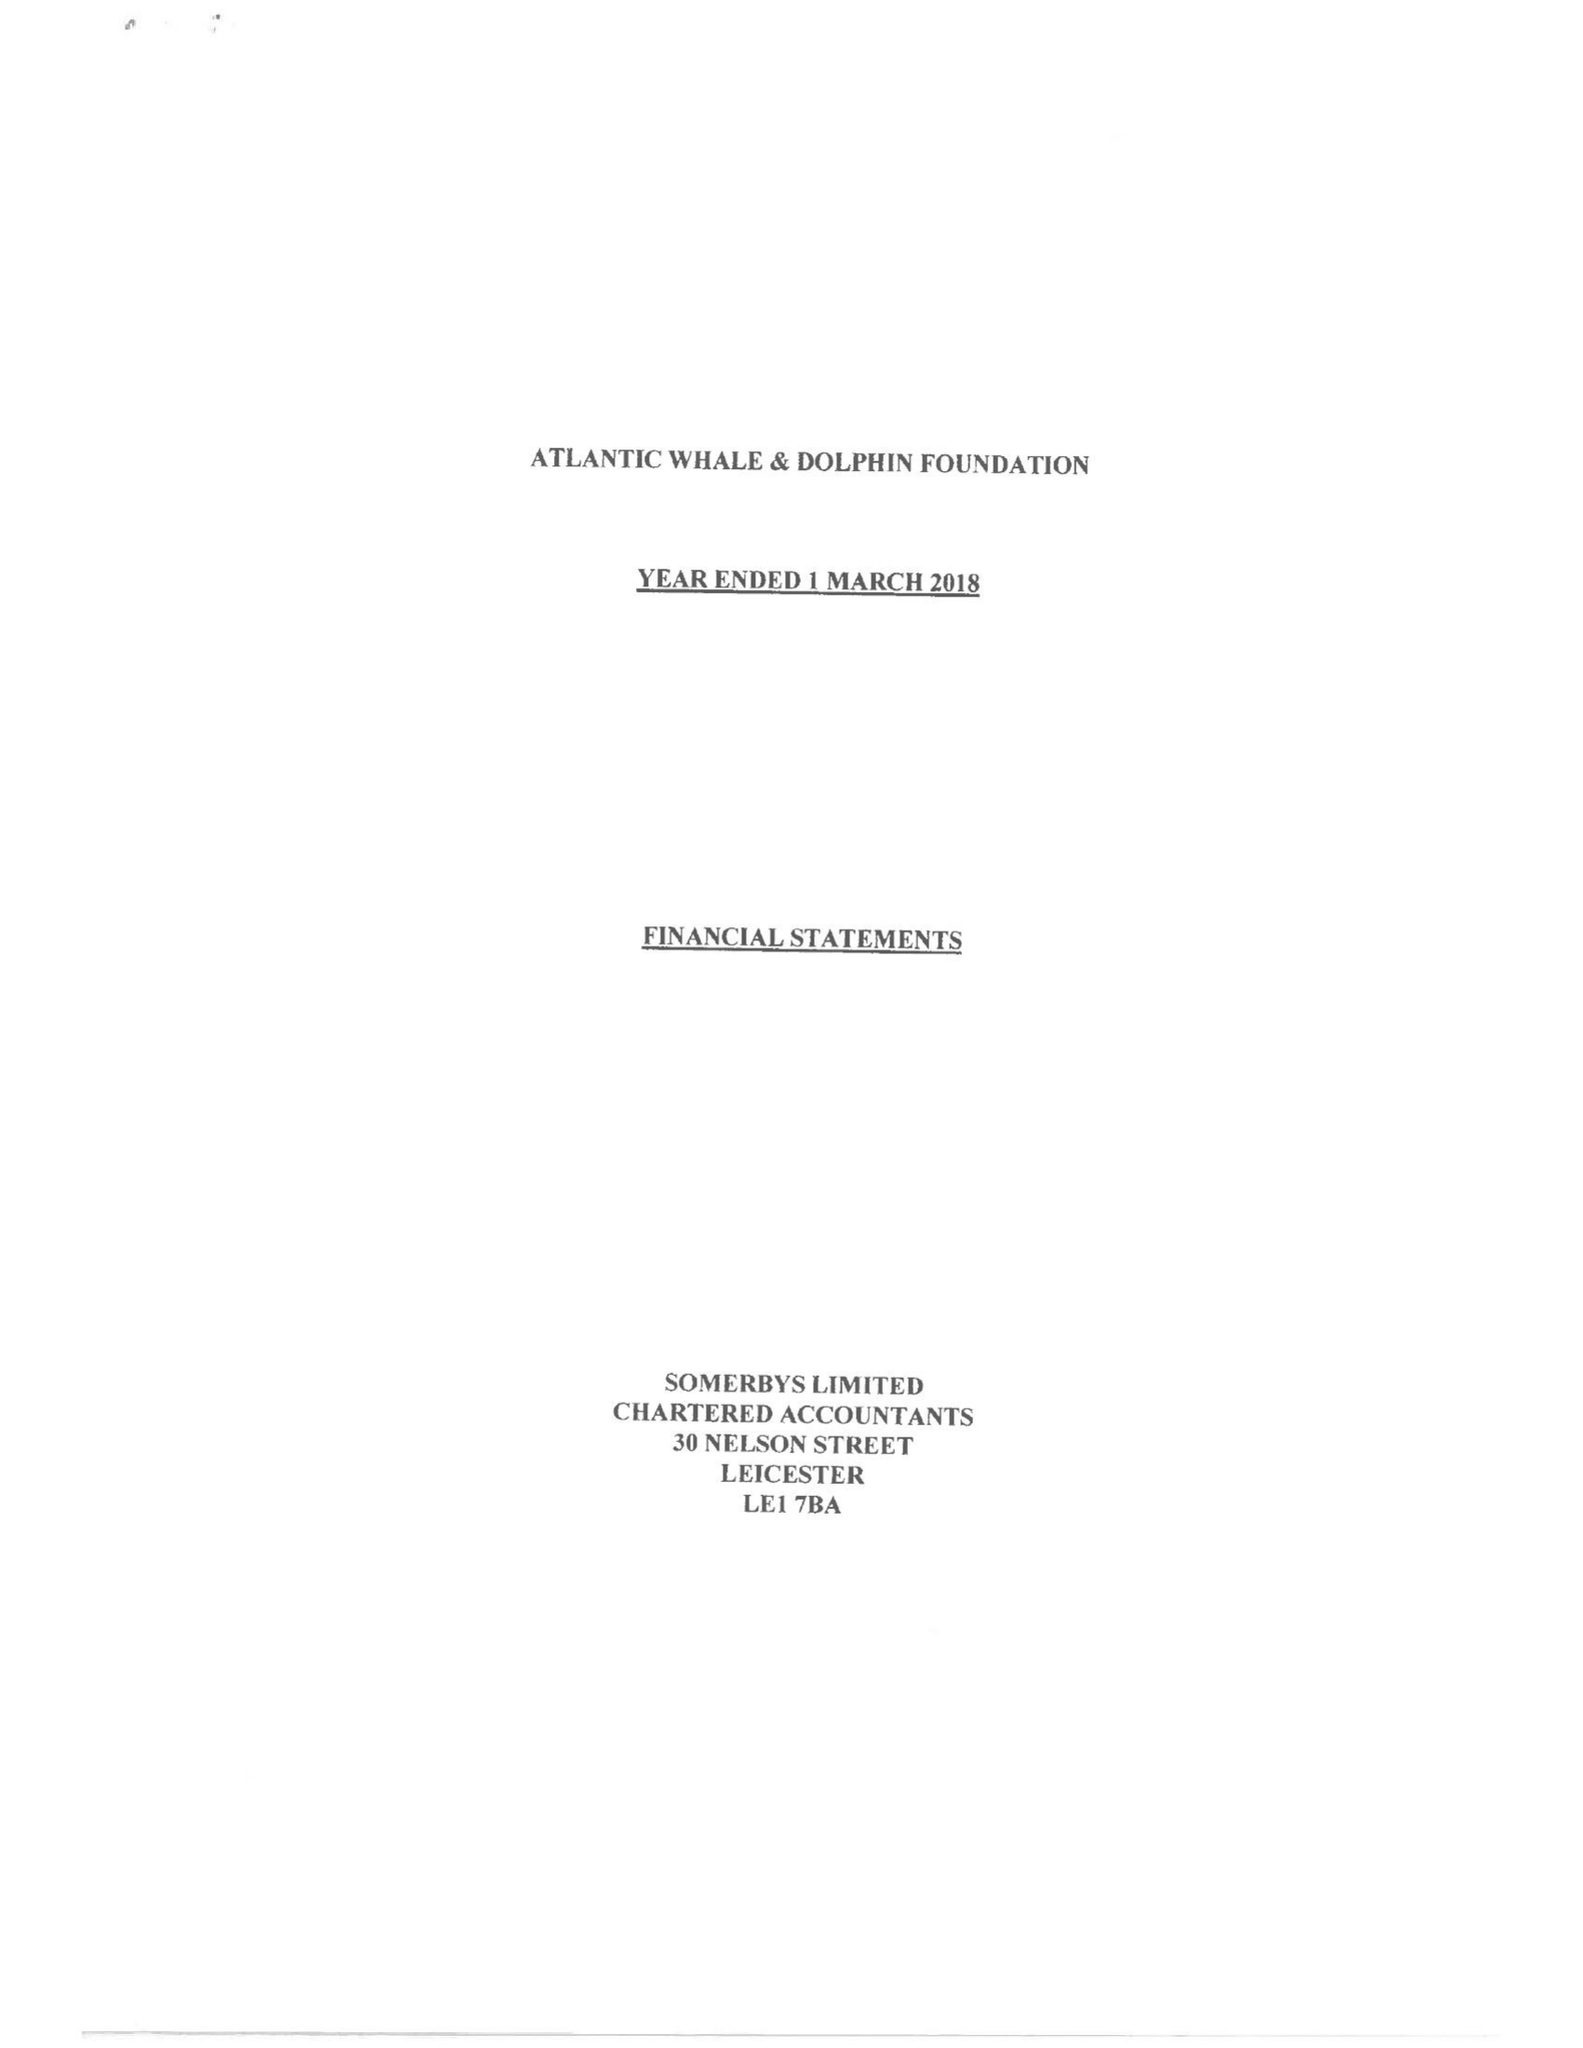What is the value for the address__street_line?
Answer the question using a single word or phrase. 43 HIGH STREET 